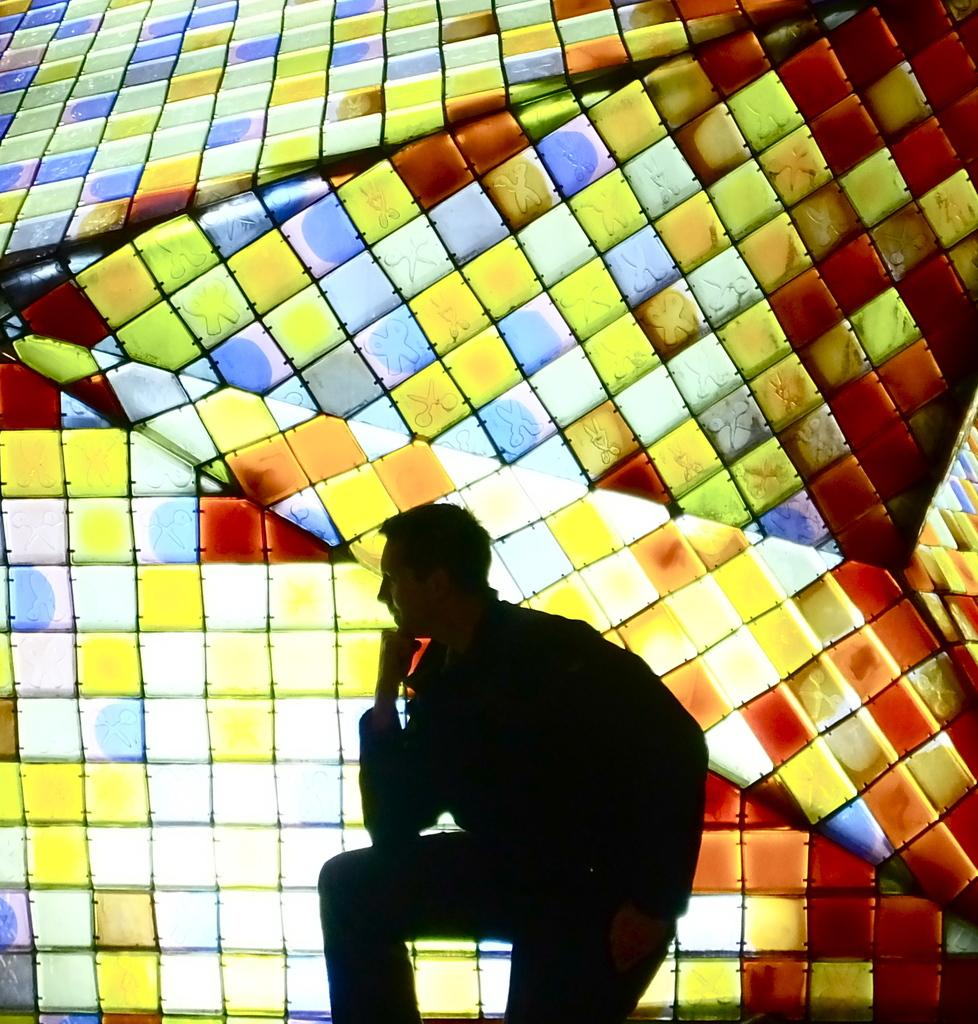What is the main subject in the foreground of the image? There is a man standing in the foreground of the image. What can be seen in the background of the image? There is a 3D painting on a glass wall in the background of the image. What type of flowers can be seen on the man's face in the image? There are no flowers or any indication of a face on the man in the image. 